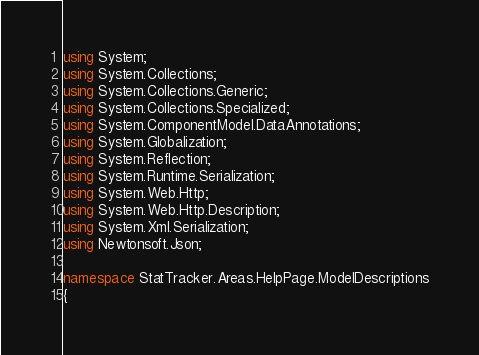Convert code to text. <code><loc_0><loc_0><loc_500><loc_500><_C#_>using System;
using System.Collections;
using System.Collections.Generic;
using System.Collections.Specialized;
using System.ComponentModel.DataAnnotations;
using System.Globalization;
using System.Reflection;
using System.Runtime.Serialization;
using System.Web.Http;
using System.Web.Http.Description;
using System.Xml.Serialization;
using Newtonsoft.Json;

namespace StatTracker.Areas.HelpPage.ModelDescriptions
{</code> 